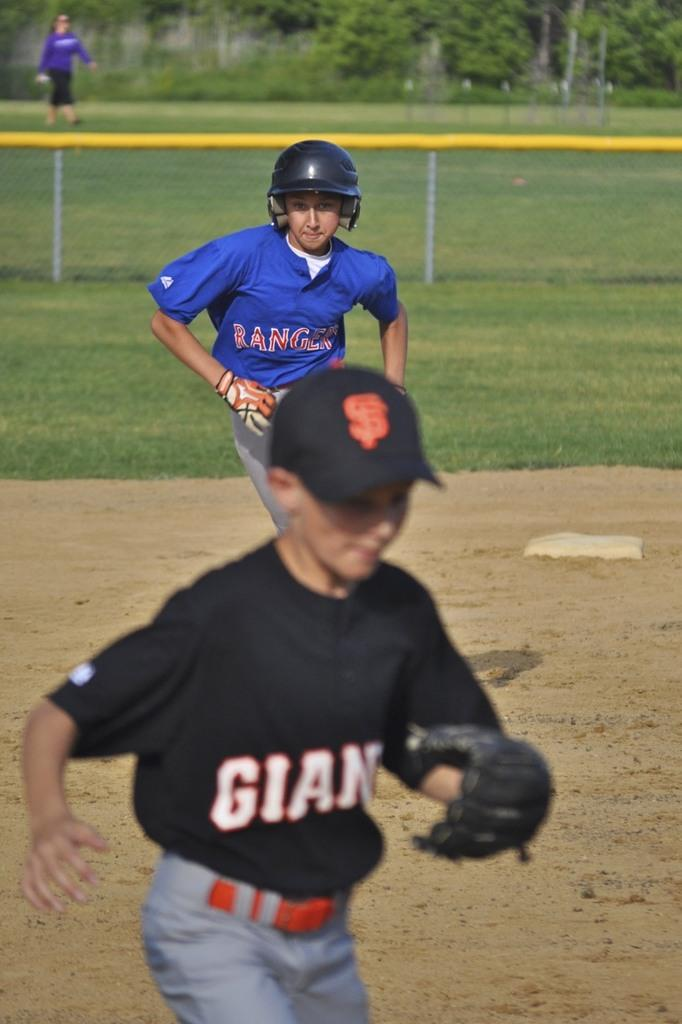<image>
Share a concise interpretation of the image provided. Two young boys are on a baseball field wearing jersey's for the Giants and the Rangers. 